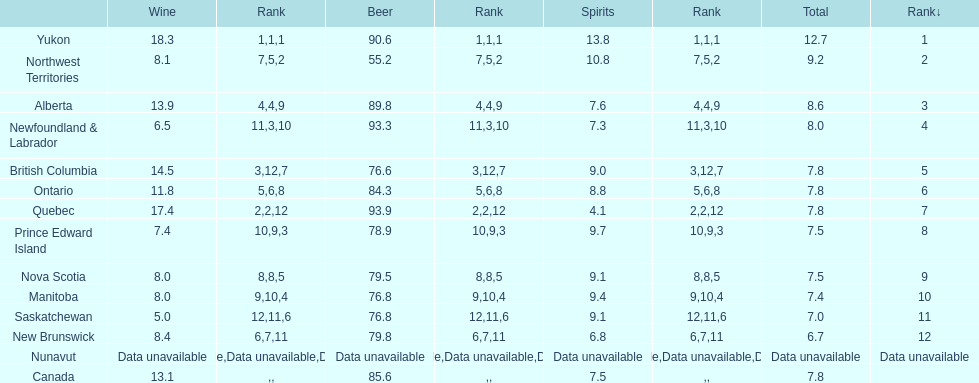Which province has the highest wine consumption rate? Yukon. 